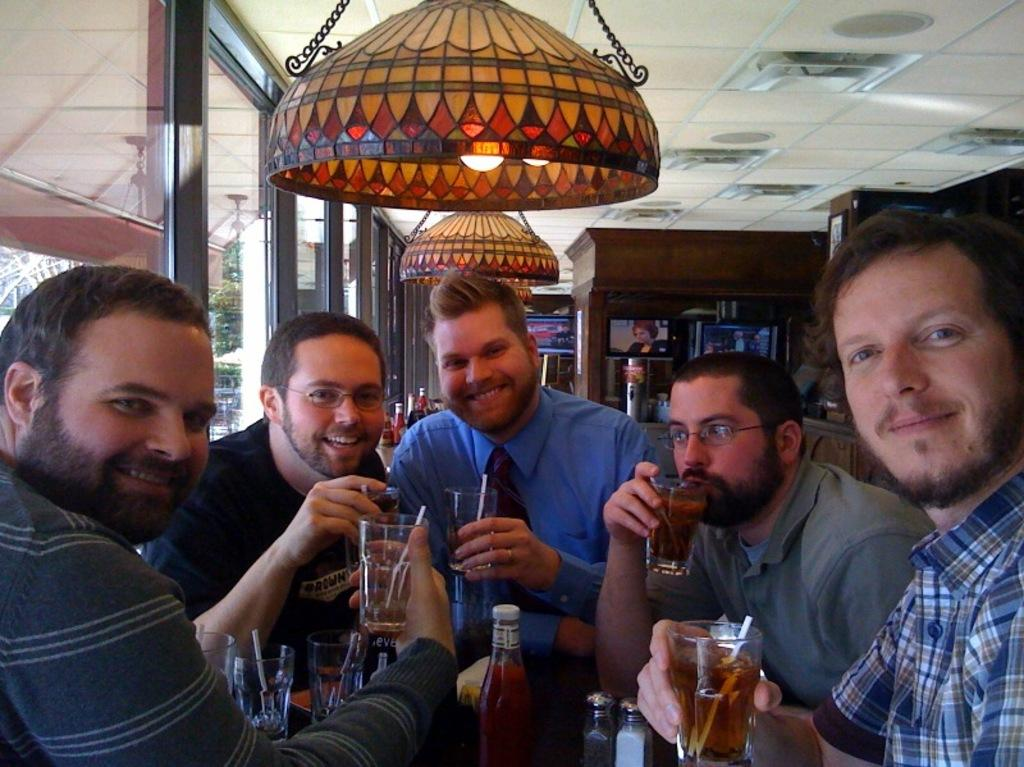What is the main subject of the image? The main subject of the image is a group of men. What are the men doing in the image? The men are smiling in the image. What are the men holding in their hands? The men are holding glasses in their hands. Can you describe the lighting in the image? There is a light visible in the image. What type of yarn is the dad using to knit in the image? There is no dad or yarn present in the image; it features a group of men holding glasses and smiling. What type of army is depicted in the image? There is no army or military theme present in the image; it features a group of men holding glasses and smiling. 